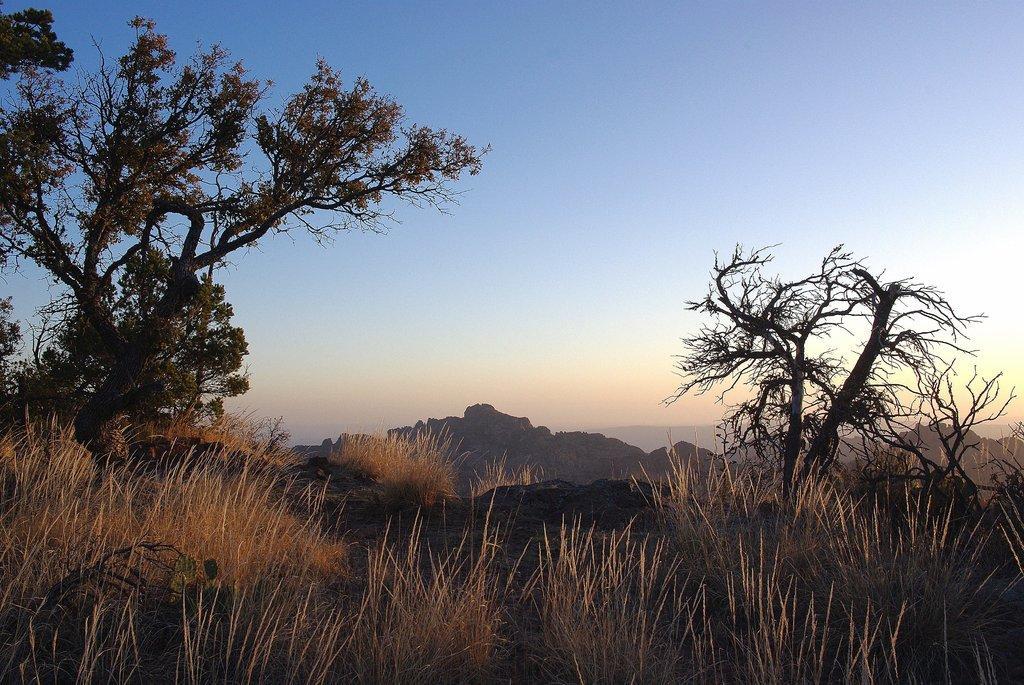Could you give a brief overview of what you see in this image? In this image I can see the sky and tree and grass and the hill. 